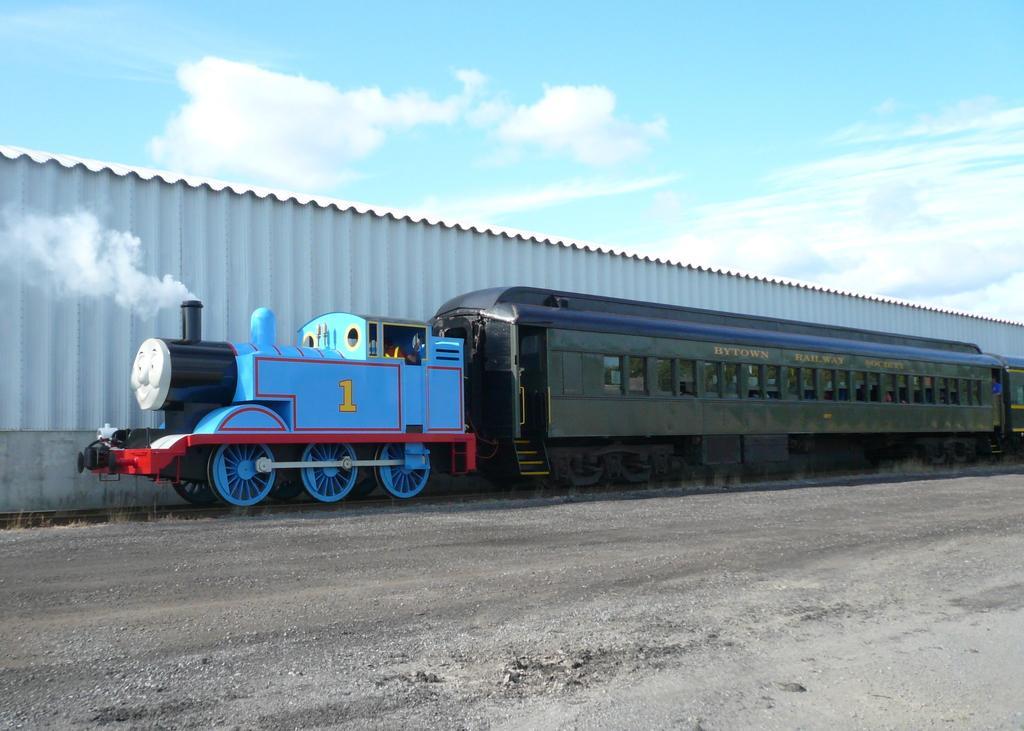In one or two sentences, can you explain what this image depicts? In the foreground of this image, there is a road. In the middle, there is a train on the track. We can also see the smoke, the metal sheet wall and the sky at the top. 